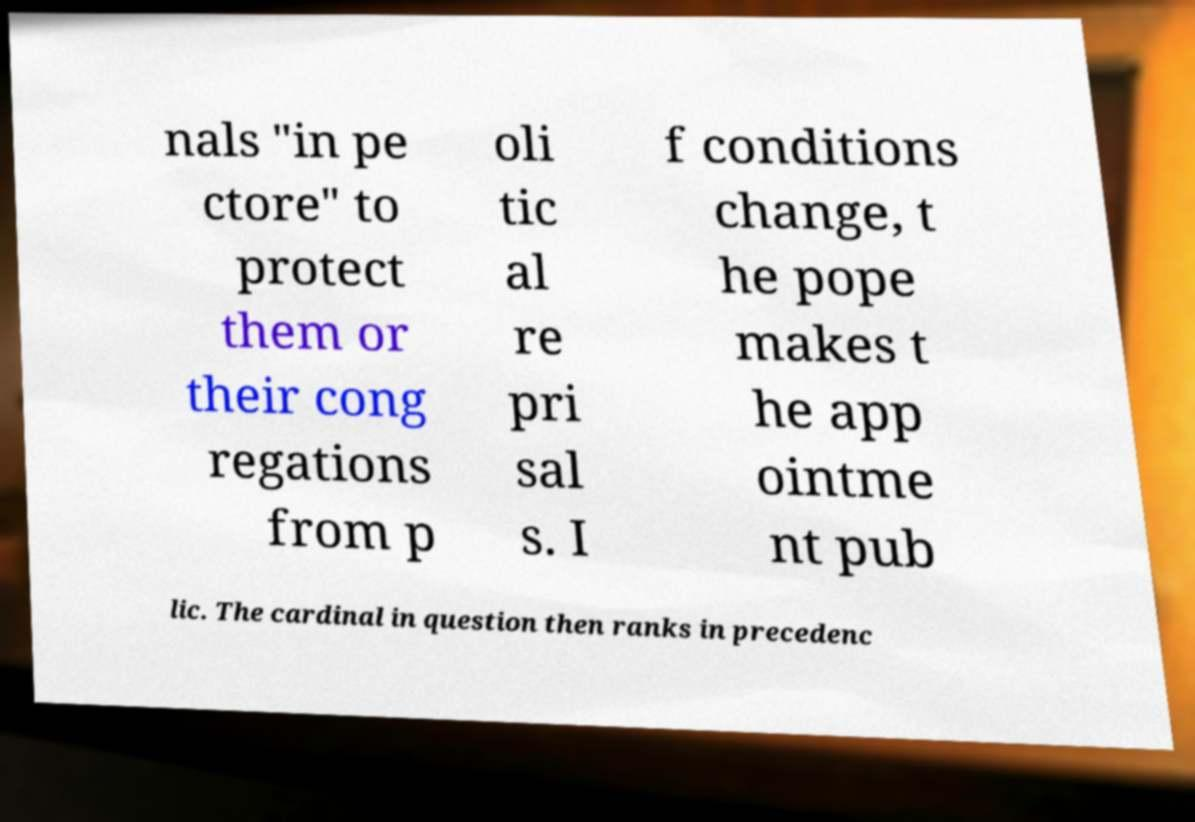Please read and relay the text visible in this image. What does it say? nals "in pe ctore" to protect them or their cong regations from p oli tic al re pri sal s. I f conditions change, t he pope makes t he app ointme nt pub lic. The cardinal in question then ranks in precedenc 